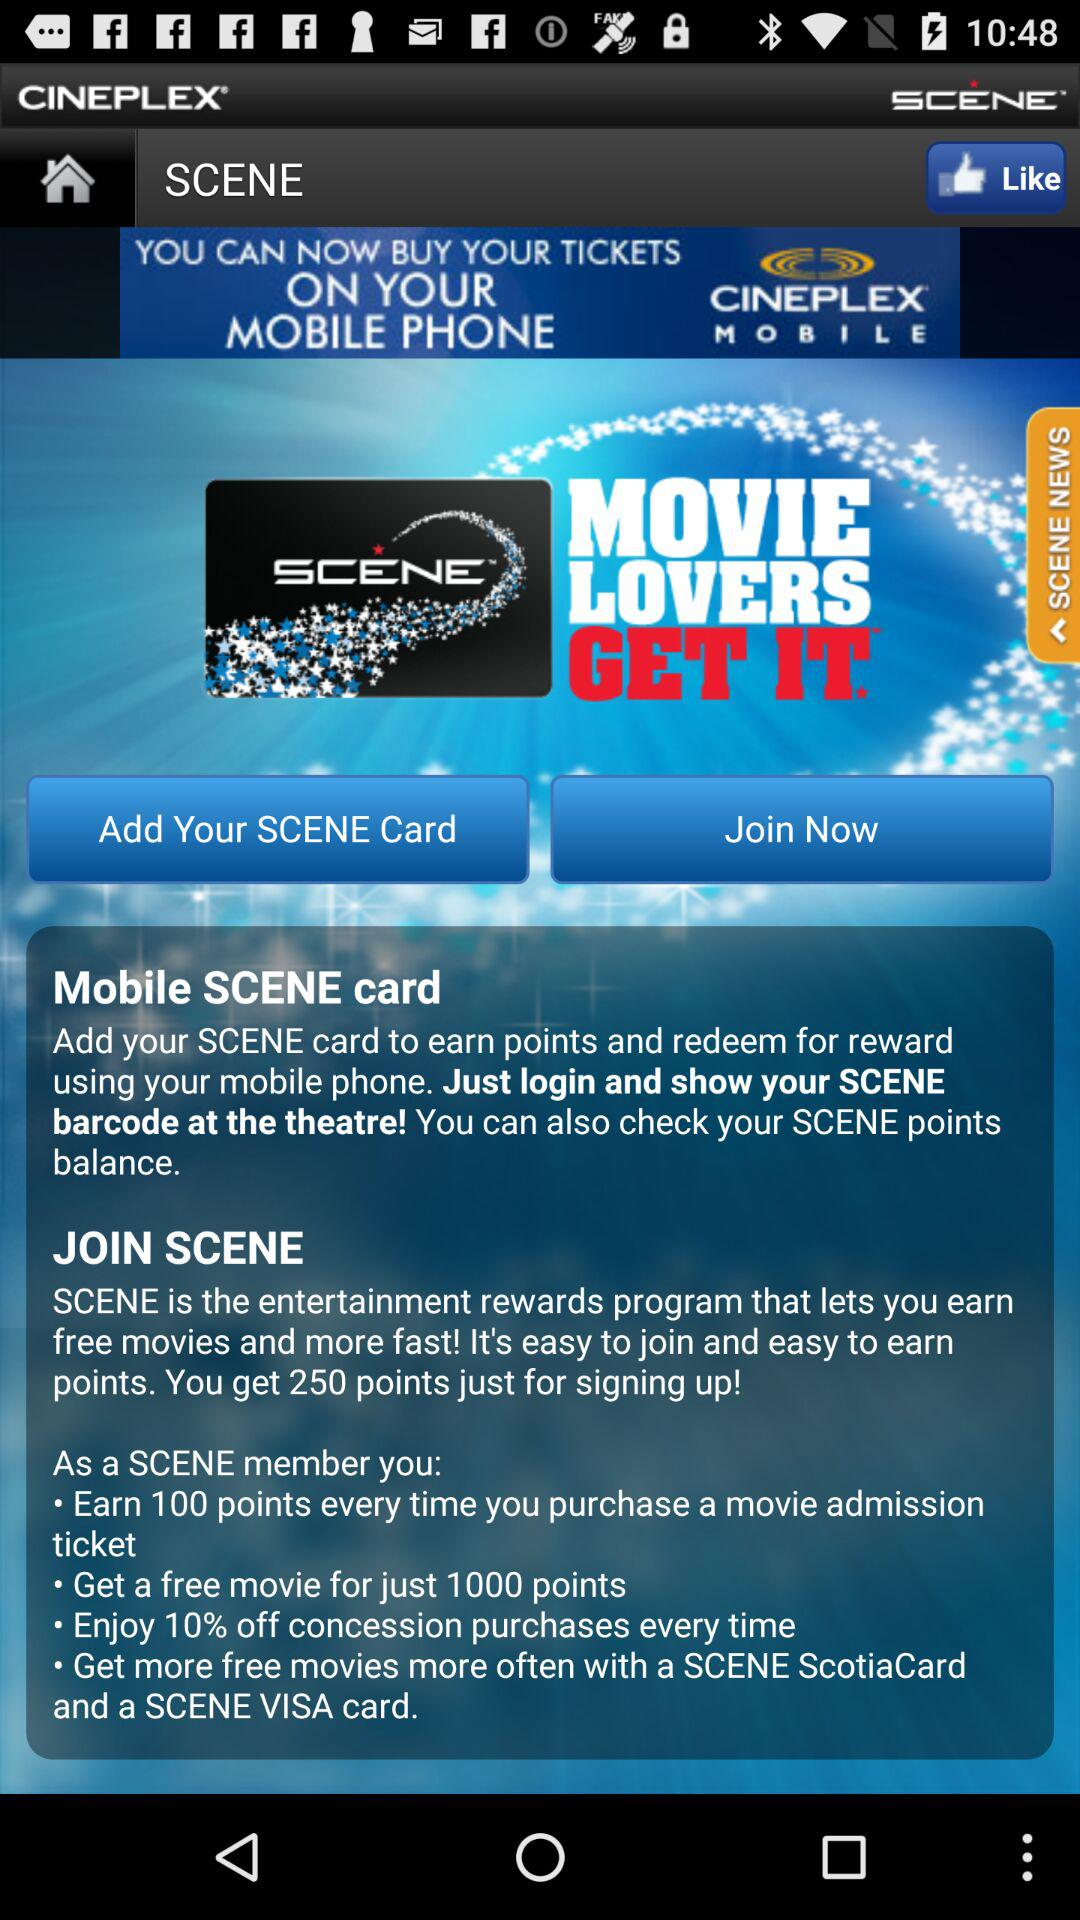How many points are earned by signing up for the application? The points earned are 250. 